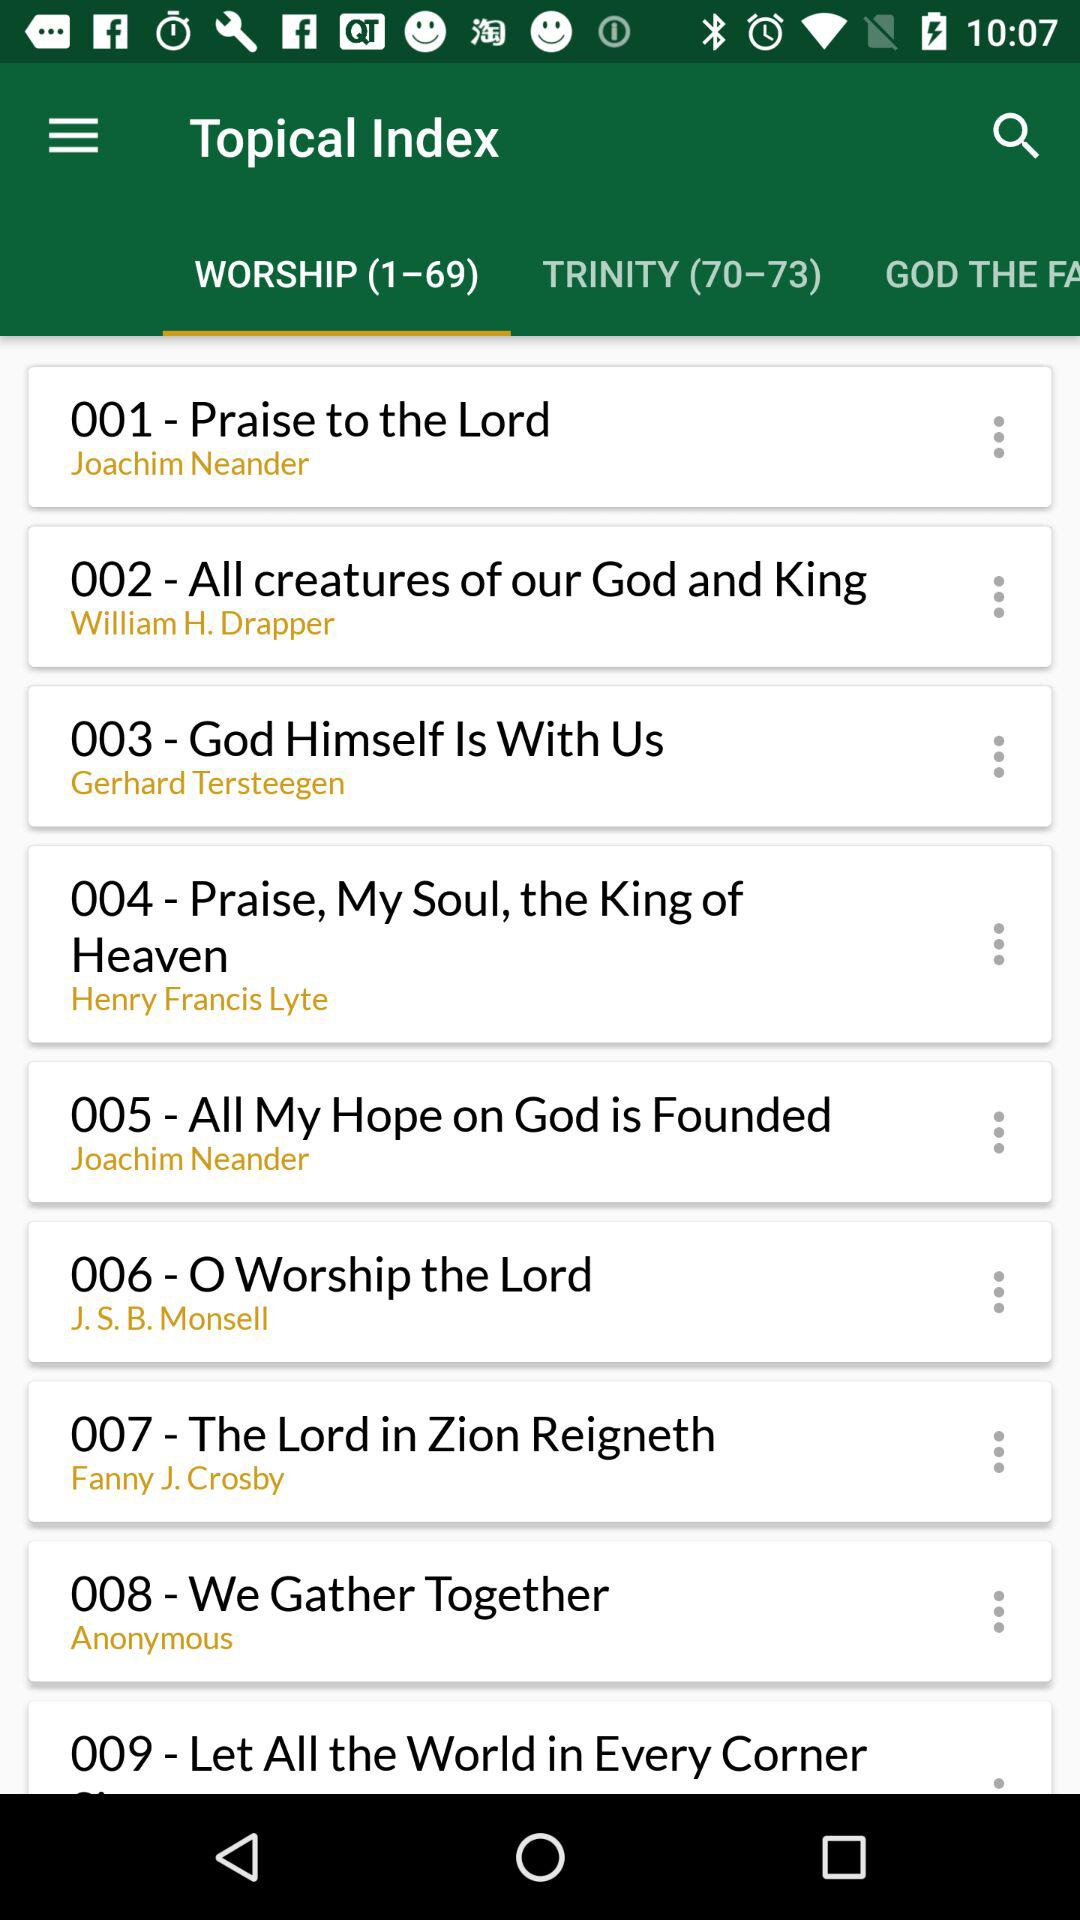Who wrote the hymn "Praise to the Lord"? The hymn "Praise to the Lord" was written by Joachim Neander. 